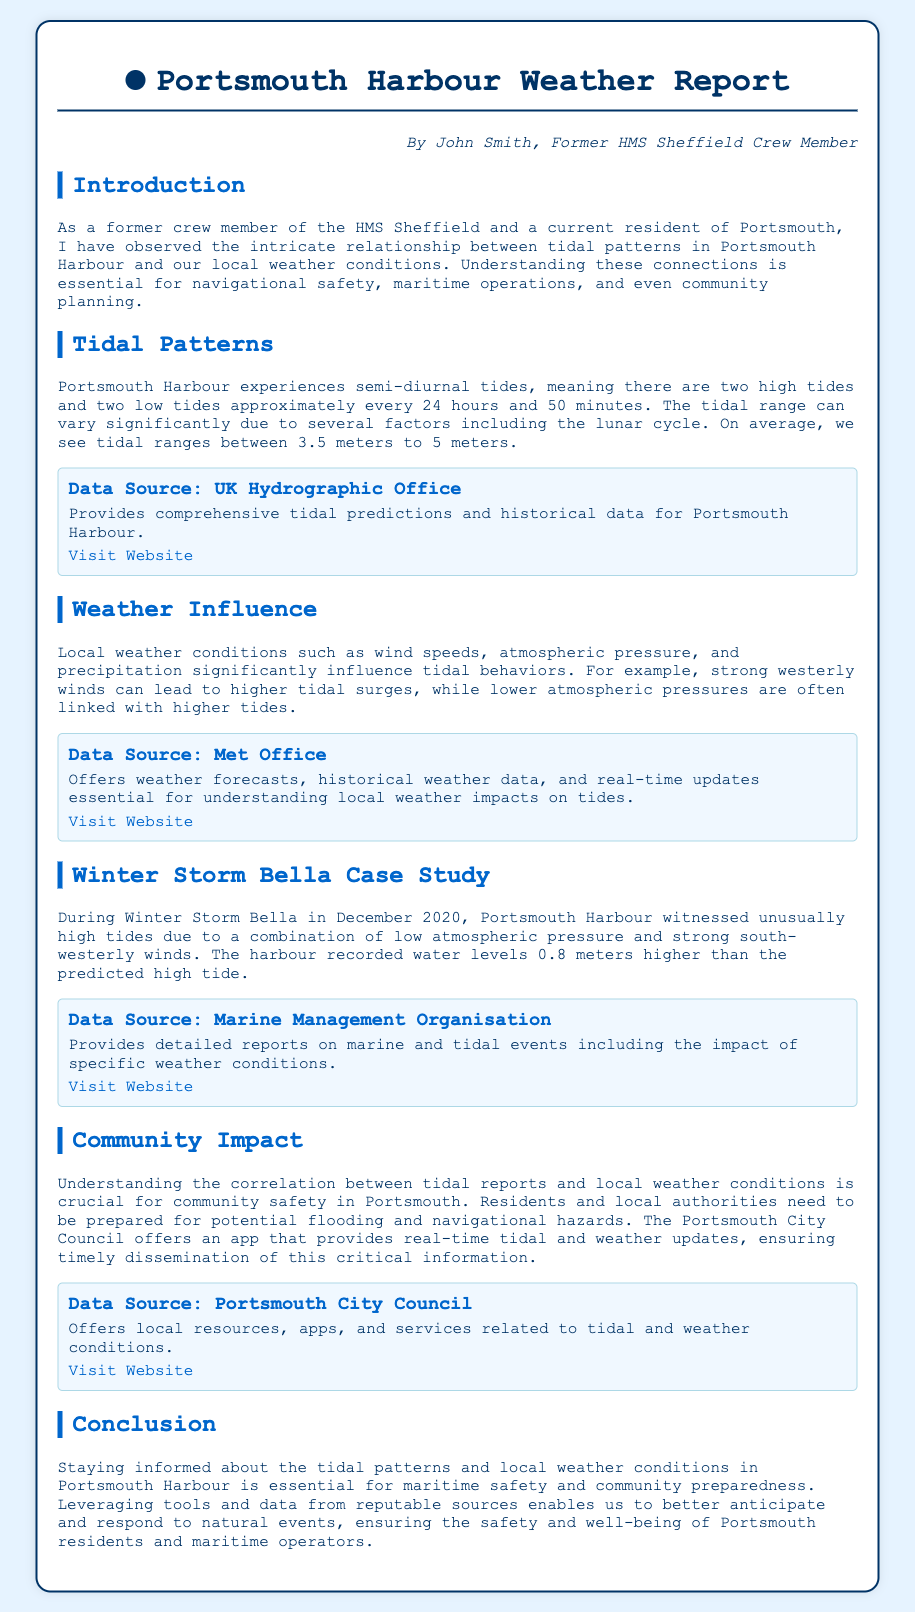What is the maximum tidal range observed in Portsmouth Harbour? The tidal range can vary significantly between 3.5 meters to 5 meters.
Answer: 5 meters Who authored the Portsmouth Harbour Weather Report? The author is listed in the document as John Smith.
Answer: John Smith What notable weather event increased tide levels in December 2020? The report mentions Winter Storm Bella as a notable weather event affecting tide levels.
Answer: Winter Storm Bella Which organization provides tidal predictions and historical data for Portsmouth Harbour? The UK Hydrographic Office is specified as the data source for tidal predictions.
Answer: UK Hydrographic Office What is one local resource provided by Portsmouth City Council? The Portsmouth City Council offers an app for tidal and weather updates, facilitating community preparedness.
Answer: Real-time tidal and weather updates app How much higher were water levels recorded during Winter Storm Bella compared to predicted high tide? The document states that water levels were 0.8 meters higher than predicted during the storm.
Answer: 0.8 meters What is the main focus of the Weather Report? The focus is on the correlation between tidal patterns and local weather conditions in Portsmouth.
Answer: Correlation between tidal patterns and local weather conditions What does strong westerly winds typically lead to in terms of tidal behavior? According to the document, strong westerly winds can lead to higher tidal surges.
Answer: Higher tidal surges 